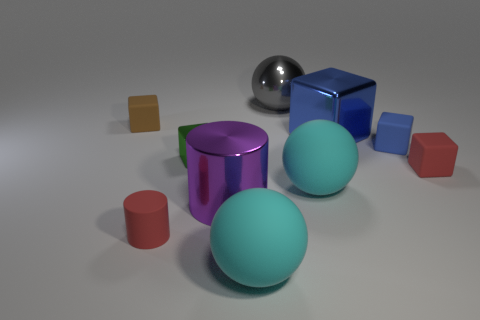Subtract all cyan spheres. How many were subtracted if there are1cyan spheres left? 1 Subtract all blue blocks. How many cyan spheres are left? 2 Subtract all shiny blocks. How many blocks are left? 3 Subtract all blue blocks. How many blocks are left? 3 Subtract 1 cylinders. How many cylinders are left? 1 Subtract 0 gray blocks. How many objects are left? 10 Subtract all cylinders. How many objects are left? 8 Subtract all gray cubes. Subtract all gray cylinders. How many cubes are left? 5 Subtract all tiny brown matte blocks. Subtract all rubber spheres. How many objects are left? 7 Add 4 small things. How many small things are left? 9 